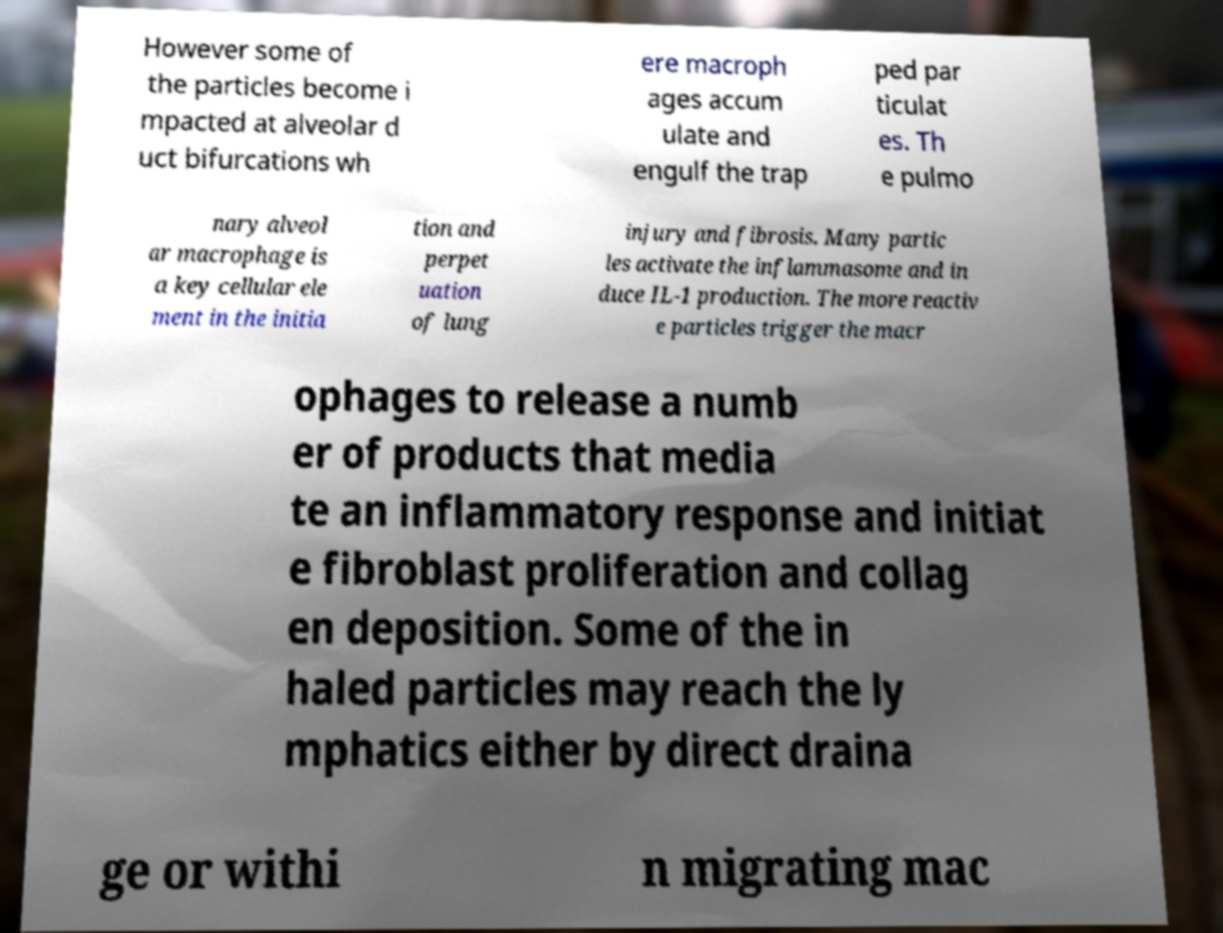Can you accurately transcribe the text from the provided image for me? However some of the particles become i mpacted at alveolar d uct bifurcations wh ere macroph ages accum ulate and engulf the trap ped par ticulat es. Th e pulmo nary alveol ar macrophage is a key cellular ele ment in the initia tion and perpet uation of lung injury and fibrosis. Many partic les activate the inflammasome and in duce IL-1 production. The more reactiv e particles trigger the macr ophages to release a numb er of products that media te an inflammatory response and initiat e fibroblast proliferation and collag en deposition. Some of the in haled particles may reach the ly mphatics either by direct draina ge or withi n migrating mac 